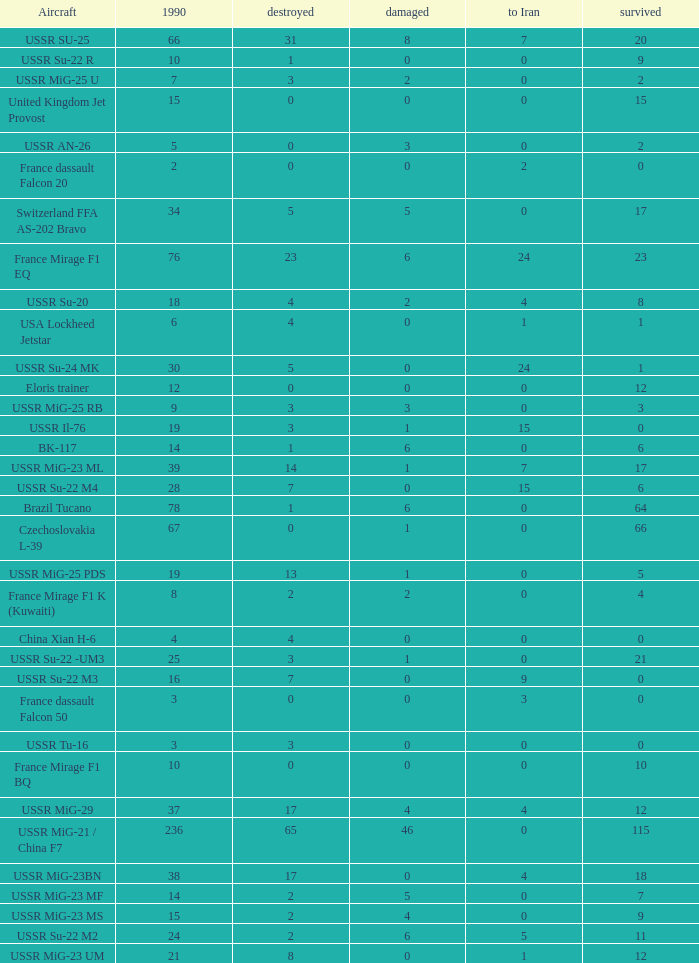If the aircraft was  ussr mig-25 rb how many were destroyed? 3.0. 